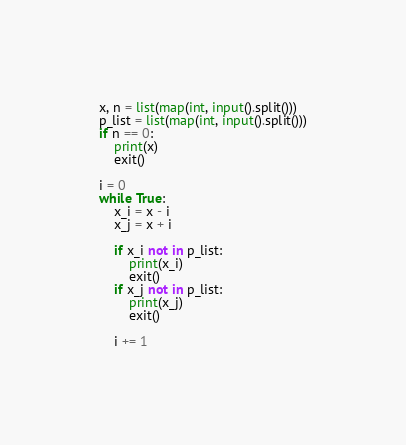<code> <loc_0><loc_0><loc_500><loc_500><_Python_>x, n = list(map(int, input().split()))
p_list = list(map(int, input().split()))
if n == 0:
    print(x)
    exit()

i = 0
while True:
    x_i = x - i
    x_j = x + i

    if x_i not in p_list:
        print(x_i)
        exit()
    if x_j not in p_list:
        print(x_j)
        exit()

    i += 1
</code> 